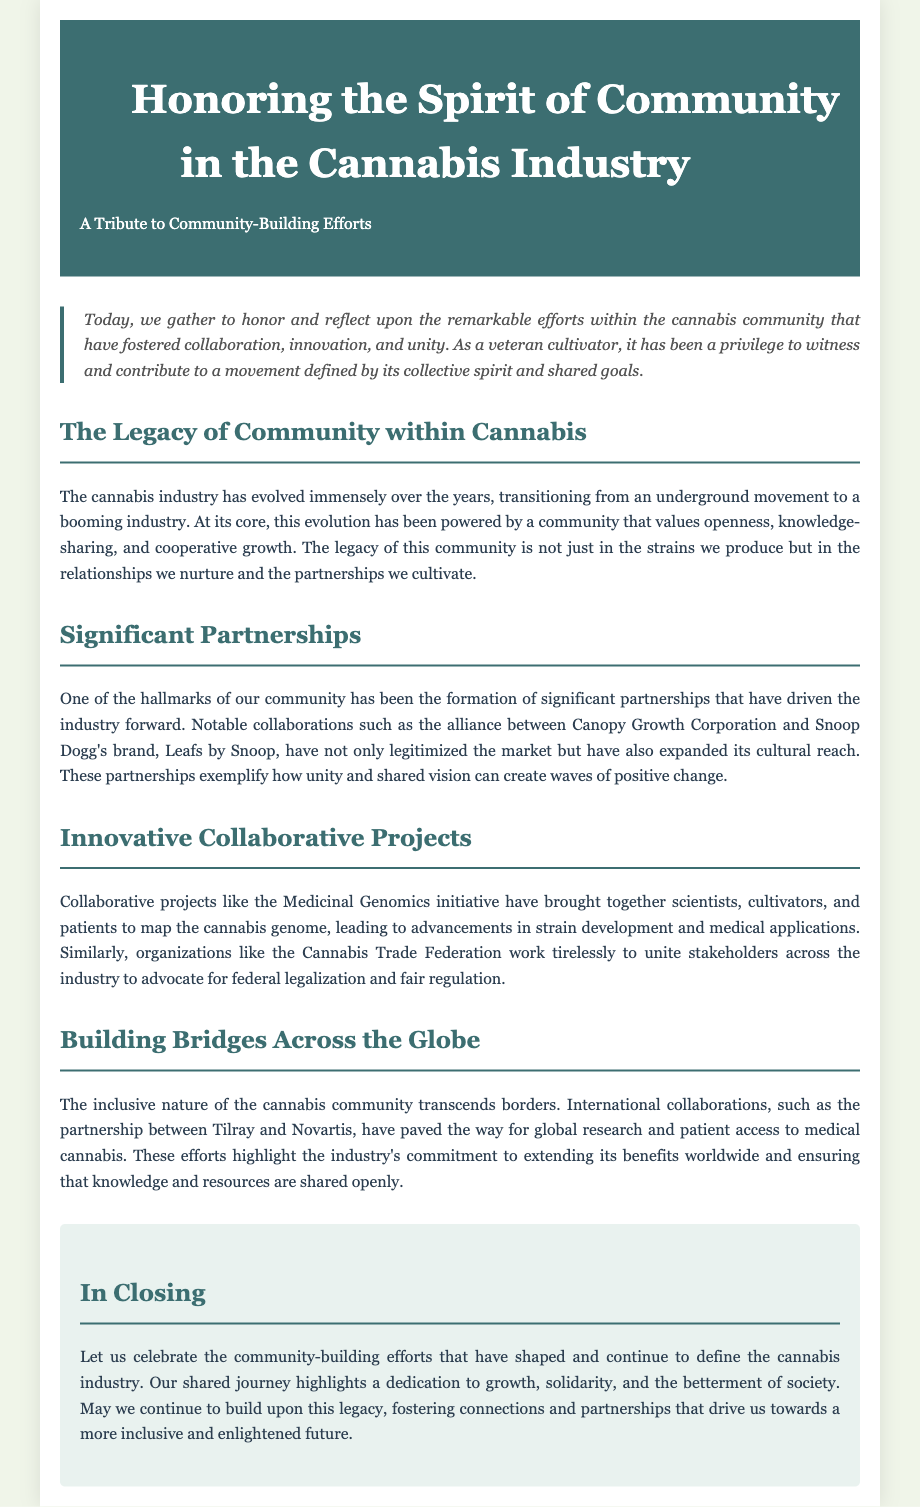What is the title of the document? The title is stated prominently in the header of the document, honoring the essence of community in the cannabis industry.
Answer: Honoring the Spirit of Community in the Cannabis Industry Who is mentioned as a notable partner in the cannabis industry? A significant partnership mentioned is between Canopy Growth Corporation and Snoop Dogg's brand, which illustrates collaboration within the industry.
Answer: Snoop Dogg What initiative is highlighted for its collaborative scientific efforts? The document mentions the Medicinal Genomics initiative as a key project that integrates various stakeholders in the cannabis community.
Answer: Medicinal Genomics What are the three core values of the cannabis community highlighted in the document? The key values emphasized include openness, knowledge-sharing, and cooperative growth as vital to the evolution of the cannabis industry.
Answer: Openness, knowledge-sharing, cooperative growth How does the document describe the nature of the cannabis community in terms of inclusivity? The document states that the cannabis community's inclusive nature transcends borders, emphasizing international collaboration.
Answer: Transcends borders What does the conclusion urge the community to do? The conclusion encourages the continuation of community-building efforts to foster connections that lead to a better future in the cannabis industry.
Answer: Celebrate community-building efforts 